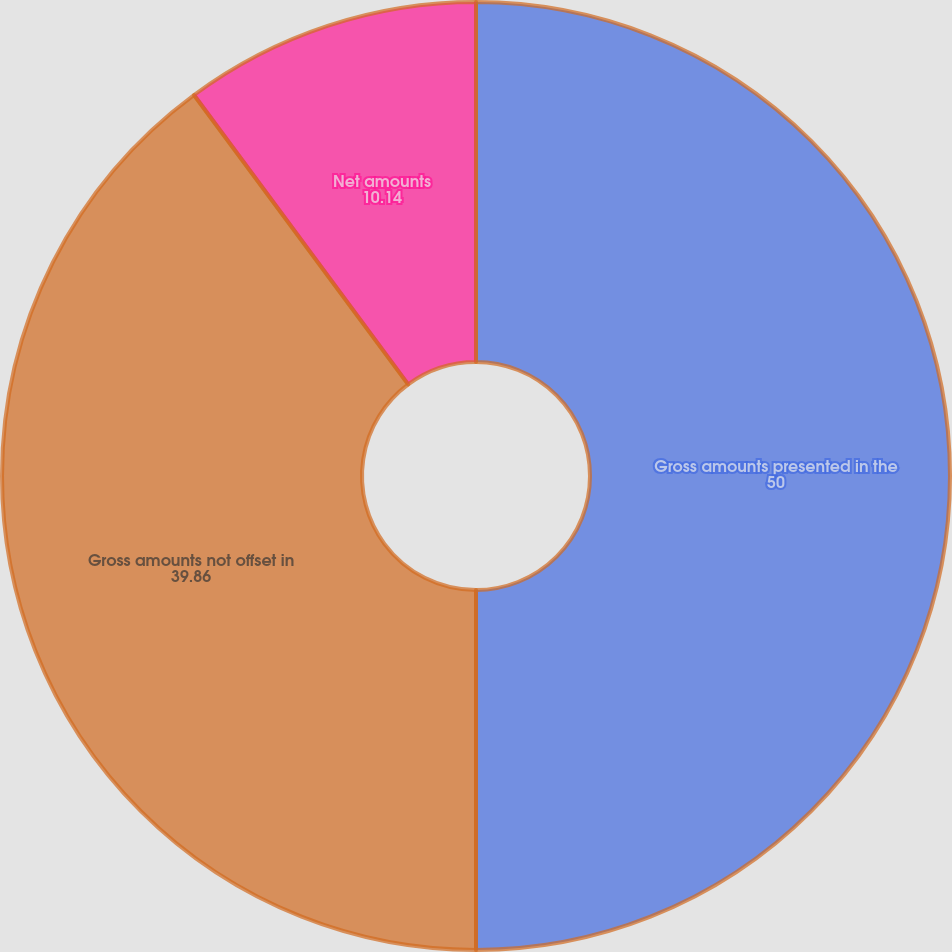Convert chart. <chart><loc_0><loc_0><loc_500><loc_500><pie_chart><fcel>Gross amounts presented in the<fcel>Gross amounts not offset in<fcel>Net amounts<nl><fcel>50.0%<fcel>39.86%<fcel>10.14%<nl></chart> 